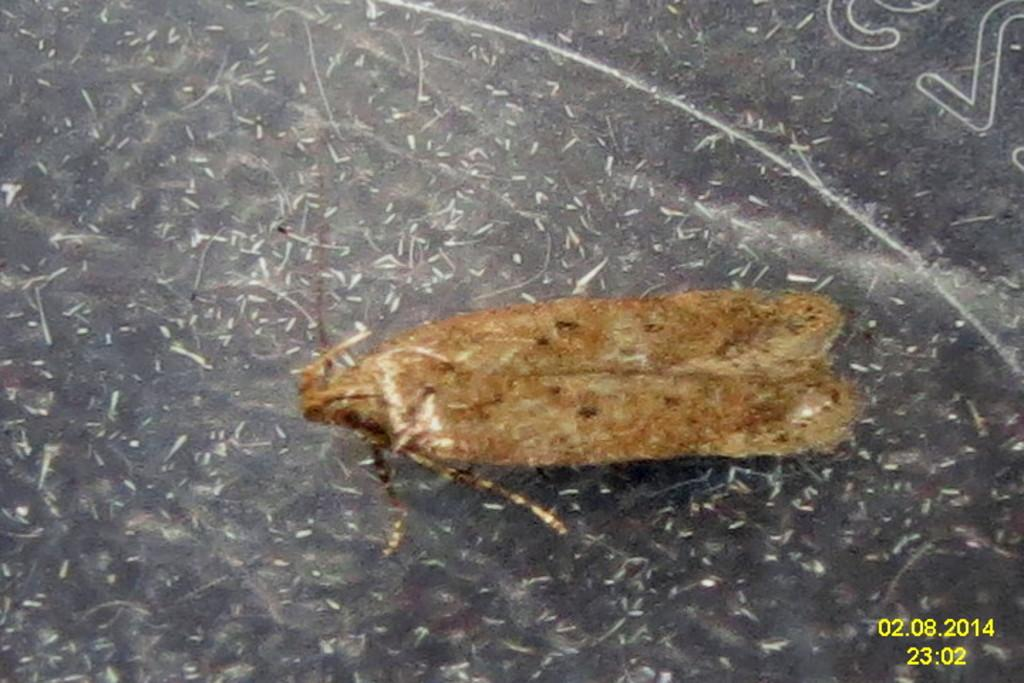What is the primary color of the surface in the image? The primary color of the surface in the image is black. What is present on the black surface? There are white dots on the black surface. What type of creature can be seen in the image? There is an insect in the image. Can you describe the insect's physical features? The insect has legs, wings, and antenna. What is the color of the insect? The insect is cream in color. What is the insect's tendency to respect itself in the image? There is no indication of the insect's tendency or self-respect in the image. The image only shows an insect with legs, wings, and antenna. 